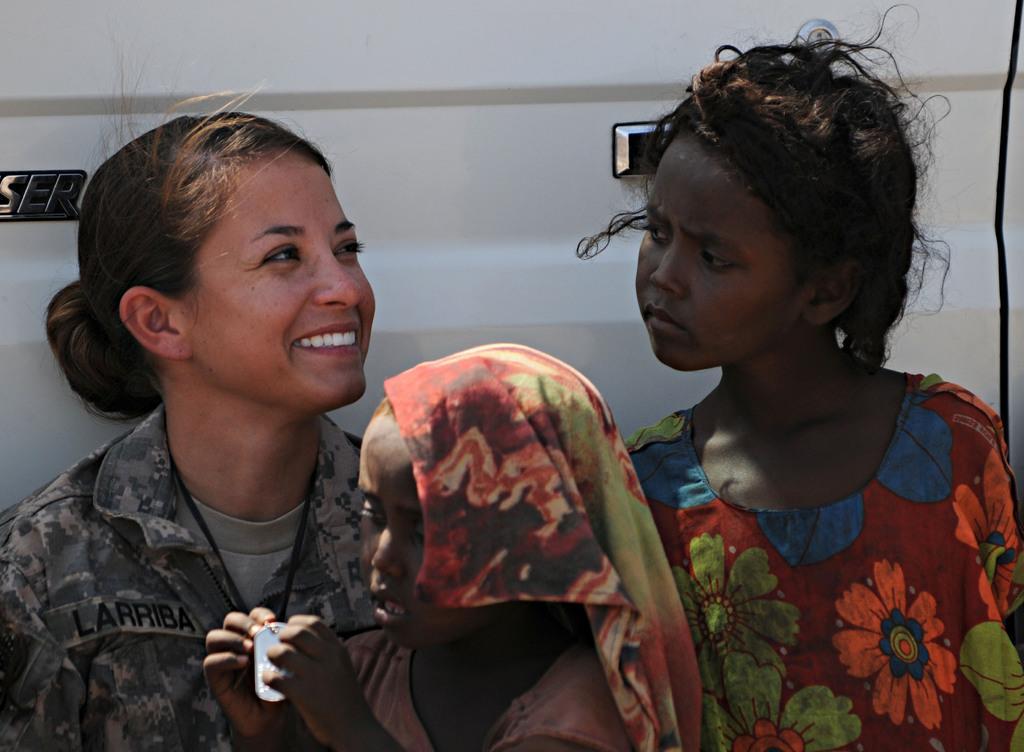In one or two sentences, can you explain what this image depicts? In this picture I can see there is a woman and two girls and in the backdrop I can see there is a white car and a door and a logo. 